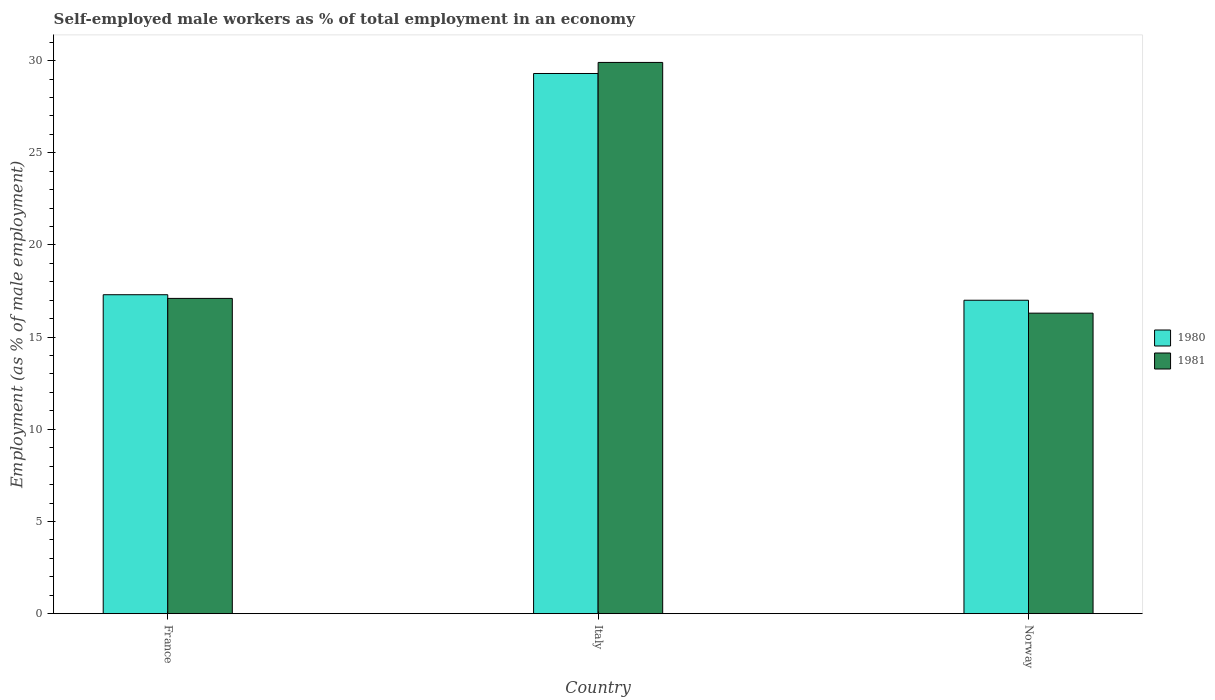How many different coloured bars are there?
Your answer should be compact. 2. How many groups of bars are there?
Offer a terse response. 3. Are the number of bars per tick equal to the number of legend labels?
Offer a terse response. Yes. What is the label of the 1st group of bars from the left?
Offer a terse response. France. What is the percentage of self-employed male workers in 1981 in France?
Offer a very short reply. 17.1. Across all countries, what is the maximum percentage of self-employed male workers in 1980?
Keep it short and to the point. 29.3. What is the total percentage of self-employed male workers in 1981 in the graph?
Make the answer very short. 63.3. What is the difference between the percentage of self-employed male workers in 1980 in Italy and that in Norway?
Your answer should be compact. 12.3. What is the difference between the percentage of self-employed male workers in 1981 in France and the percentage of self-employed male workers in 1980 in Italy?
Provide a succinct answer. -12.2. What is the average percentage of self-employed male workers in 1981 per country?
Give a very brief answer. 21.1. What is the difference between the percentage of self-employed male workers of/in 1981 and percentage of self-employed male workers of/in 1980 in Italy?
Give a very brief answer. 0.6. What is the ratio of the percentage of self-employed male workers in 1980 in France to that in Norway?
Provide a succinct answer. 1.02. Is the percentage of self-employed male workers in 1980 in Italy less than that in Norway?
Give a very brief answer. No. What is the difference between the highest and the second highest percentage of self-employed male workers in 1981?
Provide a succinct answer. -0.8. What is the difference between the highest and the lowest percentage of self-employed male workers in 1980?
Keep it short and to the point. 12.3. In how many countries, is the percentage of self-employed male workers in 1980 greater than the average percentage of self-employed male workers in 1980 taken over all countries?
Offer a terse response. 1. What does the 1st bar from the left in Italy represents?
Offer a terse response. 1980. What does the 2nd bar from the right in France represents?
Provide a short and direct response. 1980. How many bars are there?
Give a very brief answer. 6. Are all the bars in the graph horizontal?
Provide a short and direct response. No. What is the difference between two consecutive major ticks on the Y-axis?
Give a very brief answer. 5. Are the values on the major ticks of Y-axis written in scientific E-notation?
Keep it short and to the point. No. Does the graph contain any zero values?
Provide a succinct answer. No. Does the graph contain grids?
Give a very brief answer. No. Where does the legend appear in the graph?
Keep it short and to the point. Center right. How many legend labels are there?
Make the answer very short. 2. How are the legend labels stacked?
Give a very brief answer. Vertical. What is the title of the graph?
Your response must be concise. Self-employed male workers as % of total employment in an economy. Does "1973" appear as one of the legend labels in the graph?
Keep it short and to the point. No. What is the label or title of the X-axis?
Offer a very short reply. Country. What is the label or title of the Y-axis?
Provide a succinct answer. Employment (as % of male employment). What is the Employment (as % of male employment) of 1980 in France?
Ensure brevity in your answer.  17.3. What is the Employment (as % of male employment) in 1981 in France?
Provide a short and direct response. 17.1. What is the Employment (as % of male employment) in 1980 in Italy?
Give a very brief answer. 29.3. What is the Employment (as % of male employment) of 1981 in Italy?
Offer a terse response. 29.9. What is the Employment (as % of male employment) in 1980 in Norway?
Give a very brief answer. 17. What is the Employment (as % of male employment) of 1981 in Norway?
Your answer should be very brief. 16.3. Across all countries, what is the maximum Employment (as % of male employment) in 1980?
Ensure brevity in your answer.  29.3. Across all countries, what is the maximum Employment (as % of male employment) in 1981?
Ensure brevity in your answer.  29.9. Across all countries, what is the minimum Employment (as % of male employment) in 1981?
Offer a very short reply. 16.3. What is the total Employment (as % of male employment) in 1980 in the graph?
Your answer should be very brief. 63.6. What is the total Employment (as % of male employment) in 1981 in the graph?
Give a very brief answer. 63.3. What is the difference between the Employment (as % of male employment) in 1980 in France and that in Italy?
Give a very brief answer. -12. What is the difference between the Employment (as % of male employment) of 1980 in France and that in Norway?
Provide a succinct answer. 0.3. What is the difference between the Employment (as % of male employment) of 1980 in Italy and that in Norway?
Offer a terse response. 12.3. What is the difference between the Employment (as % of male employment) of 1980 in Italy and the Employment (as % of male employment) of 1981 in Norway?
Your answer should be very brief. 13. What is the average Employment (as % of male employment) of 1980 per country?
Keep it short and to the point. 21.2. What is the average Employment (as % of male employment) of 1981 per country?
Keep it short and to the point. 21.1. What is the difference between the Employment (as % of male employment) of 1980 and Employment (as % of male employment) of 1981 in France?
Ensure brevity in your answer.  0.2. What is the difference between the Employment (as % of male employment) in 1980 and Employment (as % of male employment) in 1981 in Italy?
Keep it short and to the point. -0.6. What is the ratio of the Employment (as % of male employment) of 1980 in France to that in Italy?
Offer a terse response. 0.59. What is the ratio of the Employment (as % of male employment) of 1981 in France to that in Italy?
Your response must be concise. 0.57. What is the ratio of the Employment (as % of male employment) of 1980 in France to that in Norway?
Make the answer very short. 1.02. What is the ratio of the Employment (as % of male employment) of 1981 in France to that in Norway?
Provide a succinct answer. 1.05. What is the ratio of the Employment (as % of male employment) of 1980 in Italy to that in Norway?
Make the answer very short. 1.72. What is the ratio of the Employment (as % of male employment) in 1981 in Italy to that in Norway?
Provide a succinct answer. 1.83. 